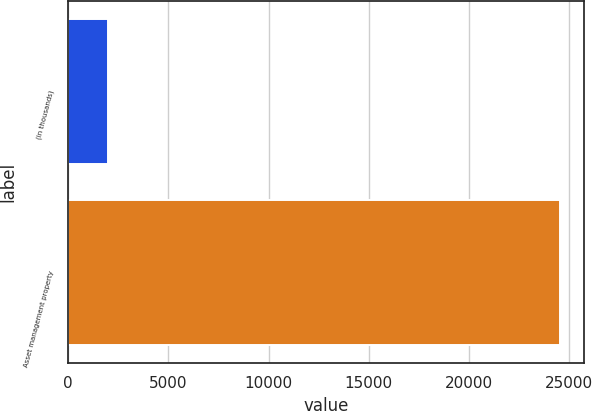Convert chart to OTSL. <chart><loc_0><loc_0><loc_500><loc_500><bar_chart><fcel>(in thousands)<fcel>Asset management property<nl><fcel>2015<fcel>24519<nl></chart> 